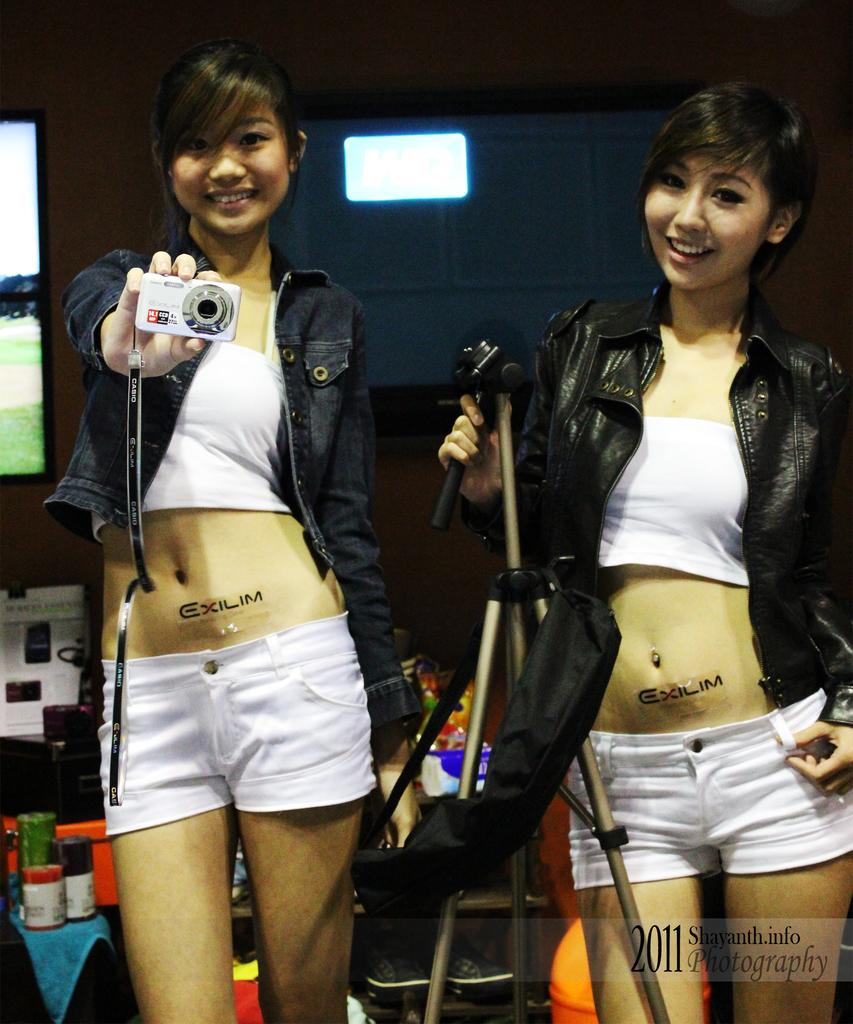How many people are in the image? There are two persons in the image. What are the persons doing in the image? The persons are standing and smiling. What are the persons holding in their hands? The persons are holding a camera in their hands. What can be seen in the background of the image? There are objects on a table in the background. What can be seen illuminating the scene in the image? There are lights visible in the image. Can you see a ship in the image? No, there is no ship present in the image. Are the persons in the image watching a wave? No, there is no wave present in the image. 